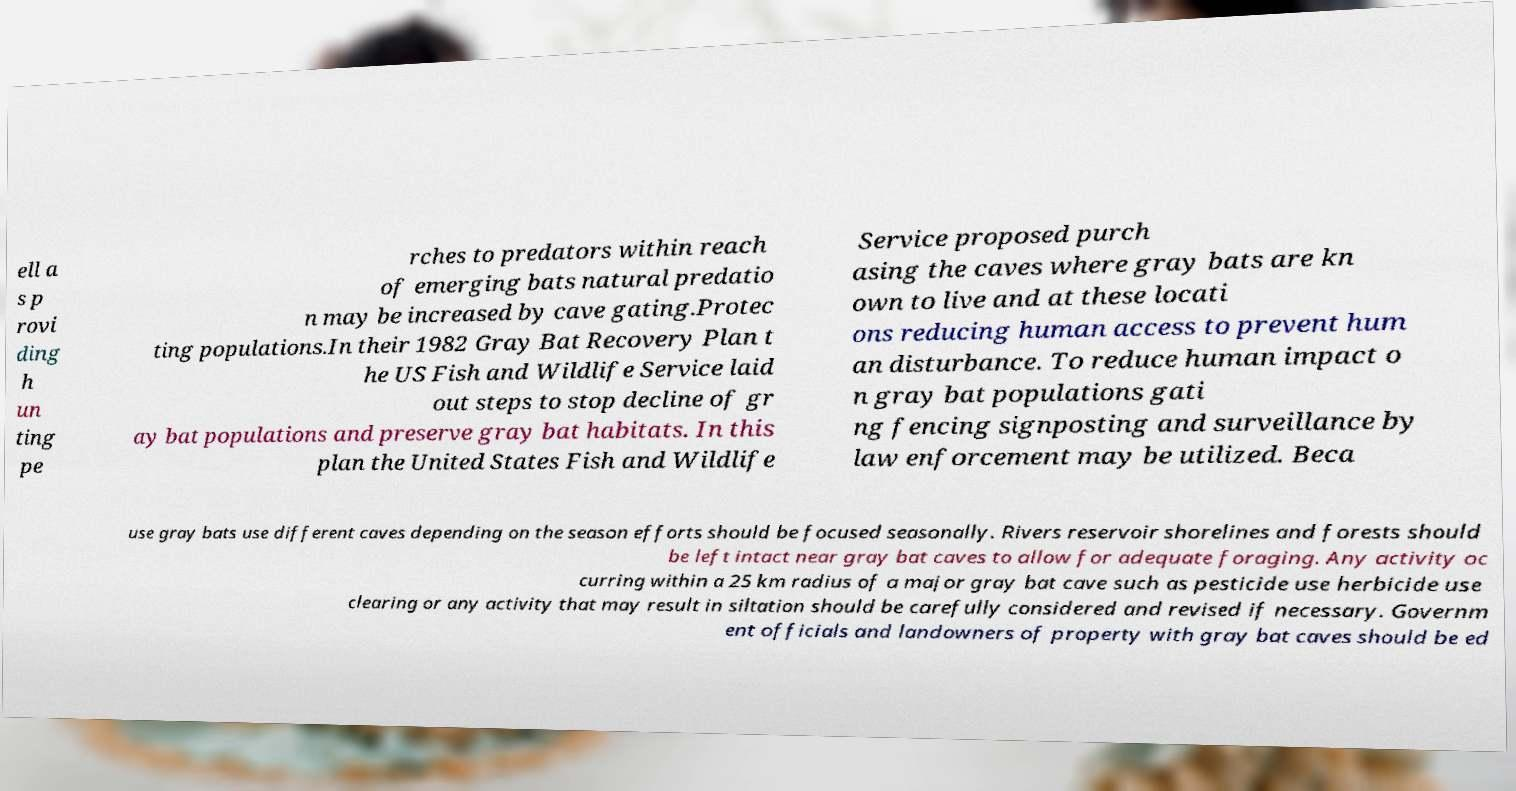Could you extract and type out the text from this image? ell a s p rovi ding h un ting pe rches to predators within reach of emerging bats natural predatio n may be increased by cave gating.Protec ting populations.In their 1982 Gray Bat Recovery Plan t he US Fish and Wildlife Service laid out steps to stop decline of gr ay bat populations and preserve gray bat habitats. In this plan the United States Fish and Wildlife Service proposed purch asing the caves where gray bats are kn own to live and at these locati ons reducing human access to prevent hum an disturbance. To reduce human impact o n gray bat populations gati ng fencing signposting and surveillance by law enforcement may be utilized. Beca use gray bats use different caves depending on the season efforts should be focused seasonally. Rivers reservoir shorelines and forests should be left intact near gray bat caves to allow for adequate foraging. Any activity oc curring within a 25 km radius of a major gray bat cave such as pesticide use herbicide use clearing or any activity that may result in siltation should be carefully considered and revised if necessary. Governm ent officials and landowners of property with gray bat caves should be ed 